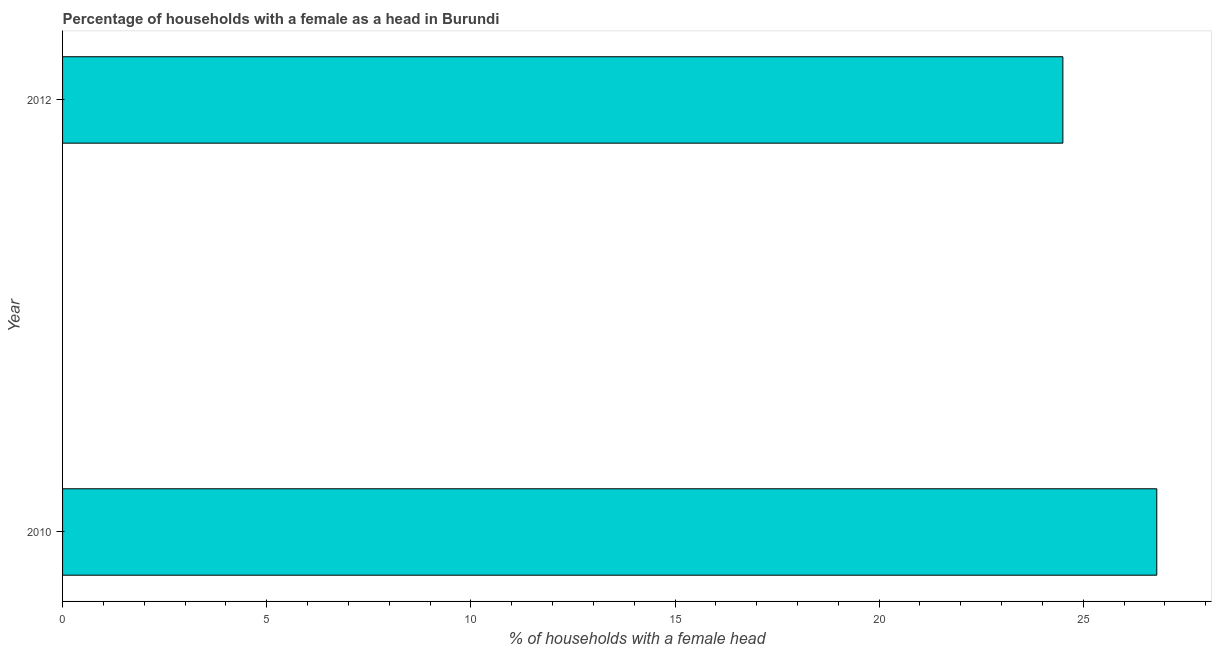Does the graph contain any zero values?
Offer a very short reply. No. What is the title of the graph?
Give a very brief answer. Percentage of households with a female as a head in Burundi. What is the label or title of the X-axis?
Keep it short and to the point. % of households with a female head. What is the number of female supervised households in 2010?
Ensure brevity in your answer.  26.8. Across all years, what is the maximum number of female supervised households?
Make the answer very short. 26.8. Across all years, what is the minimum number of female supervised households?
Give a very brief answer. 24.5. In which year was the number of female supervised households maximum?
Offer a very short reply. 2010. What is the sum of the number of female supervised households?
Keep it short and to the point. 51.3. What is the average number of female supervised households per year?
Keep it short and to the point. 25.65. What is the median number of female supervised households?
Ensure brevity in your answer.  25.65. In how many years, is the number of female supervised households greater than 12 %?
Ensure brevity in your answer.  2. Do a majority of the years between 2010 and 2012 (inclusive) have number of female supervised households greater than 12 %?
Give a very brief answer. Yes. What is the ratio of the number of female supervised households in 2010 to that in 2012?
Provide a short and direct response. 1.09. Is the number of female supervised households in 2010 less than that in 2012?
Keep it short and to the point. No. How many bars are there?
Your response must be concise. 2. What is the difference between two consecutive major ticks on the X-axis?
Provide a short and direct response. 5. What is the % of households with a female head of 2010?
Provide a short and direct response. 26.8. What is the % of households with a female head in 2012?
Keep it short and to the point. 24.5. What is the ratio of the % of households with a female head in 2010 to that in 2012?
Your response must be concise. 1.09. 